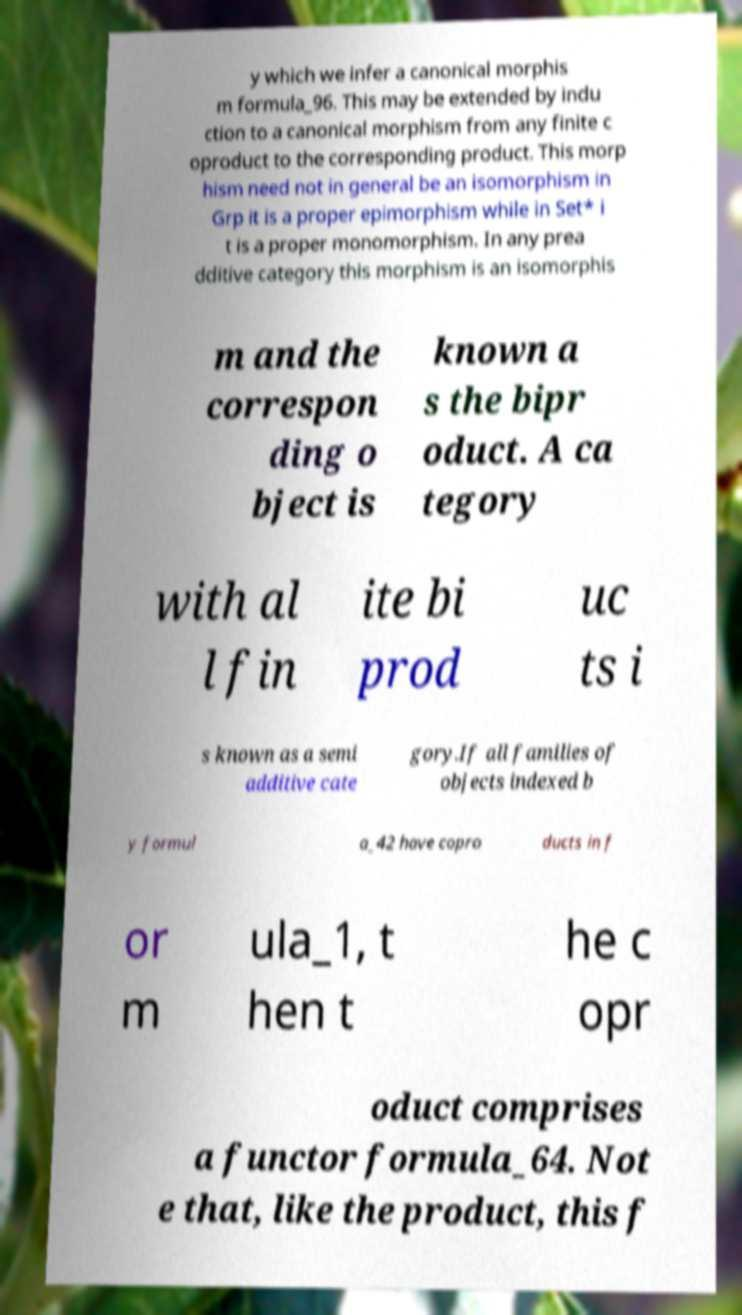Could you assist in decoding the text presented in this image and type it out clearly? y which we infer a canonical morphis m formula_96. This may be extended by indu ction to a canonical morphism from any finite c oproduct to the corresponding product. This morp hism need not in general be an isomorphism in Grp it is a proper epimorphism while in Set* i t is a proper monomorphism. In any prea dditive category this morphism is an isomorphis m and the correspon ding o bject is known a s the bipr oduct. A ca tegory with al l fin ite bi prod uc ts i s known as a semi additive cate gory.If all families of objects indexed b y formul a_42 have copro ducts in f or m ula_1, t hen t he c opr oduct comprises a functor formula_64. Not e that, like the product, this f 